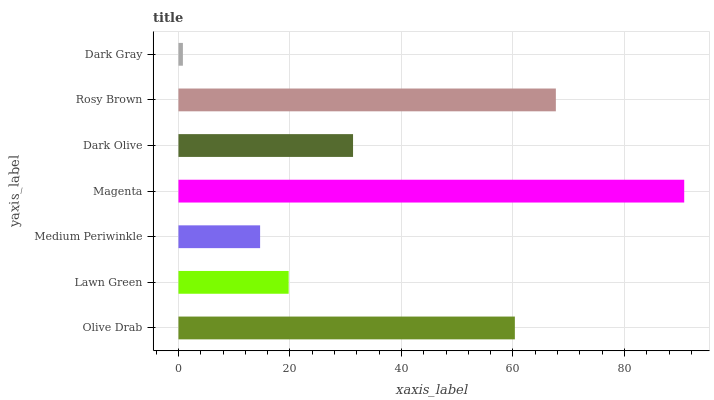Is Dark Gray the minimum?
Answer yes or no. Yes. Is Magenta the maximum?
Answer yes or no. Yes. Is Lawn Green the minimum?
Answer yes or no. No. Is Lawn Green the maximum?
Answer yes or no. No. Is Olive Drab greater than Lawn Green?
Answer yes or no. Yes. Is Lawn Green less than Olive Drab?
Answer yes or no. Yes. Is Lawn Green greater than Olive Drab?
Answer yes or no. No. Is Olive Drab less than Lawn Green?
Answer yes or no. No. Is Dark Olive the high median?
Answer yes or no. Yes. Is Dark Olive the low median?
Answer yes or no. Yes. Is Lawn Green the high median?
Answer yes or no. No. Is Rosy Brown the low median?
Answer yes or no. No. 